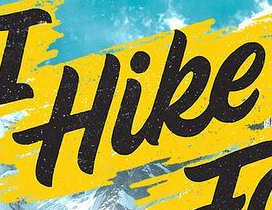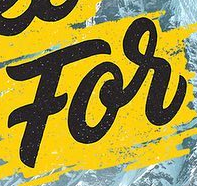Identify the words shown in these images in order, separated by a semicolon. Hike; For 